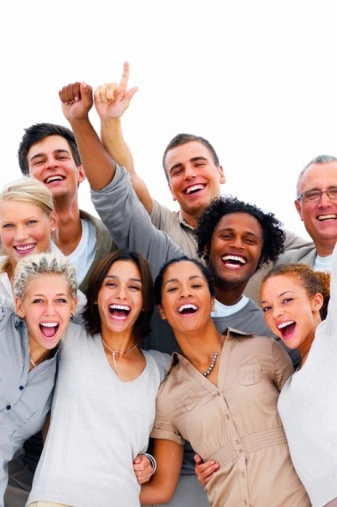who is the suspect I'm not sure who the suspect is. Can you give me more information? who is the suspect you must choose one It is not possible to determine which of these people is a suspect based on the photo. 